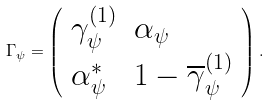Convert formula to latex. <formula><loc_0><loc_0><loc_500><loc_500>\Gamma _ { \psi } = \left ( \begin{array} { l l } \gamma _ { \psi } ^ { ( 1 ) } & \alpha _ { \psi } \\ \alpha _ { \psi } ^ { * } & 1 - \overline { \gamma } _ { \psi } ^ { ( 1 ) } \end{array} \right ) .</formula> 